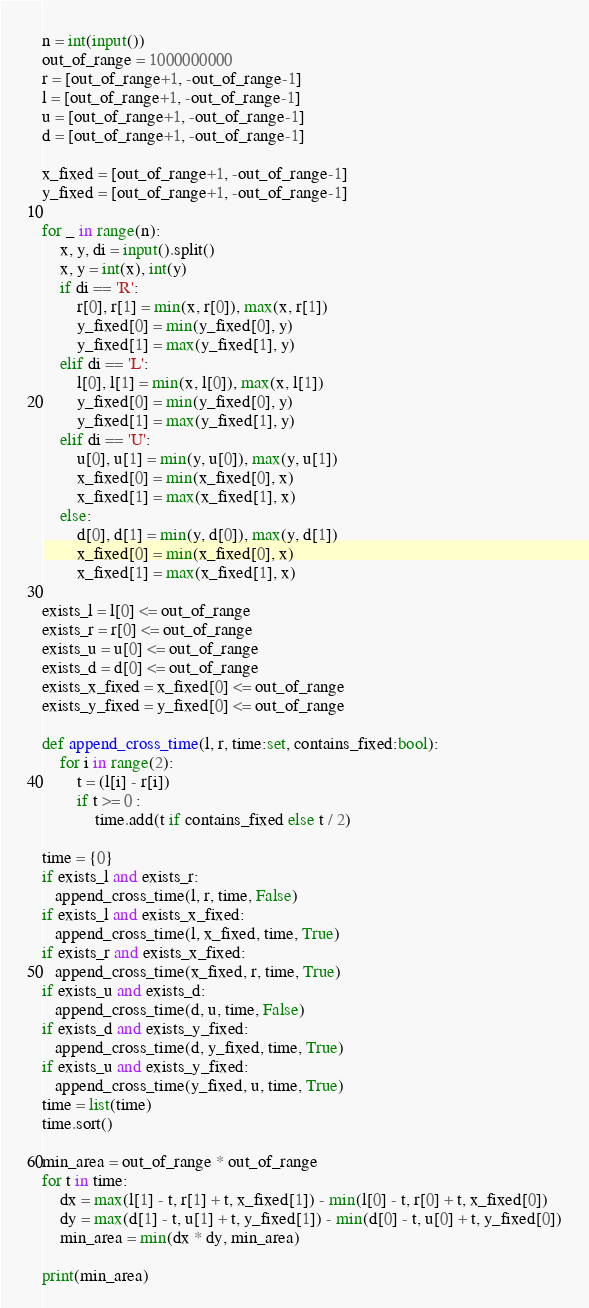Convert code to text. <code><loc_0><loc_0><loc_500><loc_500><_Python_>n = int(input())
out_of_range = 1000000000
r = [out_of_range+1, -out_of_range-1]
l = [out_of_range+1, -out_of_range-1]
u = [out_of_range+1, -out_of_range-1]
d = [out_of_range+1, -out_of_range-1]

x_fixed = [out_of_range+1, -out_of_range-1]
y_fixed = [out_of_range+1, -out_of_range-1]

for _ in range(n):
    x, y, di = input().split()
    x, y = int(x), int(y)
    if di == 'R':
        r[0], r[1] = min(x, r[0]), max(x, r[1])
        y_fixed[0] = min(y_fixed[0], y)
        y_fixed[1] = max(y_fixed[1], y)
    elif di == 'L':
        l[0], l[1] = min(x, l[0]), max(x, l[1])
        y_fixed[0] = min(y_fixed[0], y)
        y_fixed[1] = max(y_fixed[1], y)
    elif di == 'U':
        u[0], u[1] = min(y, u[0]), max(y, u[1])
        x_fixed[0] = min(x_fixed[0], x)
        x_fixed[1] = max(x_fixed[1], x)
    else:
        d[0], d[1] = min(y, d[0]), max(y, d[1])
        x_fixed[0] = min(x_fixed[0], x)
        x_fixed[1] = max(x_fixed[1], x)

exists_l = l[0] <= out_of_range
exists_r = r[0] <= out_of_range
exists_u = u[0] <= out_of_range
exists_d = d[0] <= out_of_range
exists_x_fixed = x_fixed[0] <= out_of_range
exists_y_fixed = y_fixed[0] <= out_of_range

def append_cross_time(l, r, time:set, contains_fixed:bool):
    for i in range(2):
        t = (l[i] - r[i])
        if t >= 0 :
            time.add(t if contains_fixed else t / 2)

time = {0}
if exists_l and exists_r:
   append_cross_time(l, r, time, False)
if exists_l and exists_x_fixed:
   append_cross_time(l, x_fixed, time, True)
if exists_r and exists_x_fixed:
   append_cross_time(x_fixed, r, time, True)
if exists_u and exists_d:
   append_cross_time(d, u, time, False)
if exists_d and exists_y_fixed:
   append_cross_time(d, y_fixed, time, True)
if exists_u and exists_y_fixed:
   append_cross_time(y_fixed, u, time, True)
time = list(time)
time.sort()

min_area = out_of_range * out_of_range
for t in time:
    dx = max(l[1] - t, r[1] + t, x_fixed[1]) - min(l[0] - t, r[0] + t, x_fixed[0])
    dy = max(d[1] - t, u[1] + t, y_fixed[1]) - min(d[0] - t, u[0] + t, y_fixed[0])
    min_area = min(dx * dy, min_area)

print(min_area)</code> 